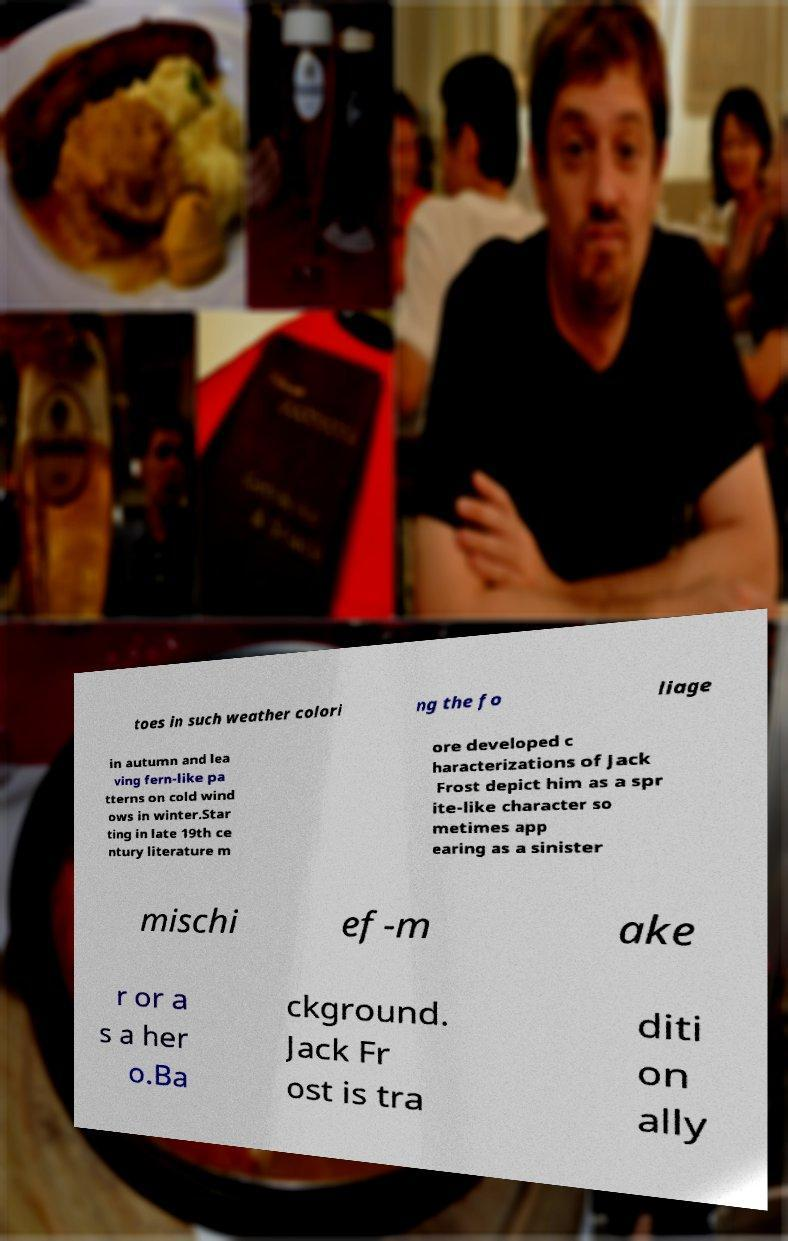Please identify and transcribe the text found in this image. toes in such weather colori ng the fo liage in autumn and lea ving fern-like pa tterns on cold wind ows in winter.Star ting in late 19th ce ntury literature m ore developed c haracterizations of Jack Frost depict him as a spr ite-like character so metimes app earing as a sinister mischi ef-m ake r or a s a her o.Ba ckground. Jack Fr ost is tra diti on ally 